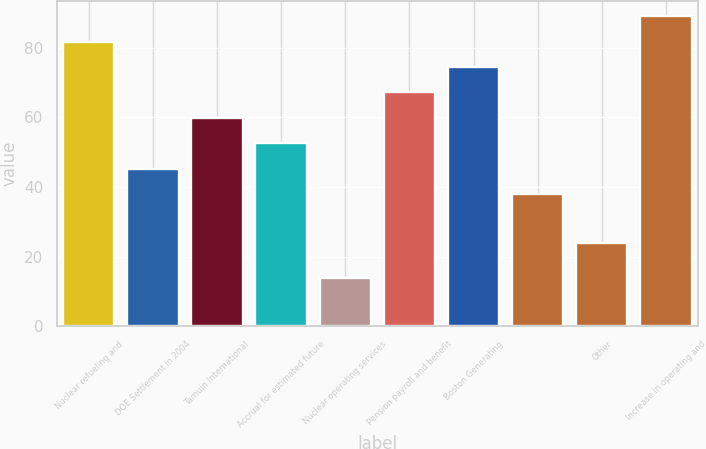<chart> <loc_0><loc_0><loc_500><loc_500><bar_chart><fcel>Nuclear refueling and<fcel>DOE Settlement in 2004<fcel>Tamuin International<fcel>Accrual for estimated future<fcel>Nuclear operating services<fcel>Pension payroll and benefit<fcel>Boston Generating<fcel>Unnamed: 7<fcel>Other<fcel>Increase in operating and<nl><fcel>81.8<fcel>45.3<fcel>59.9<fcel>52.6<fcel>14<fcel>67.2<fcel>74.5<fcel>38<fcel>24<fcel>89.1<nl></chart> 